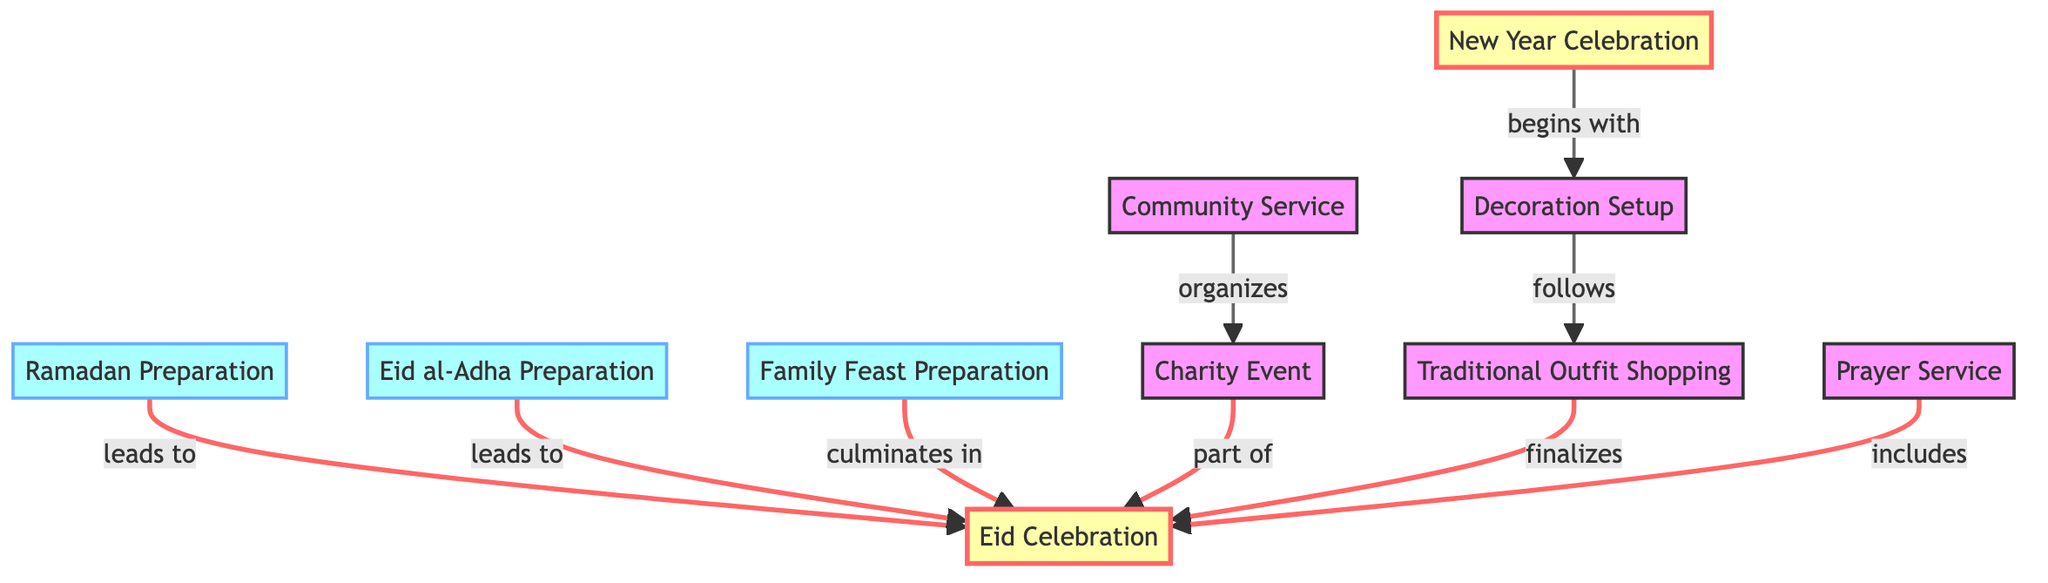What are the nodes representing preparation activities? The nodes that represent preparation activities are identified in the diagram as any node leading to the Eid Celebration. These include Ramadan Preparation, Eid al-Adha Preparation, Family Feast Preparation, Decoration Setup, and Traditional Outfit Shopping.
Answer: Ramadan Preparation, Eid al-Adha Preparation, Family Feast Preparation, Decoration Setup, Traditional Outfit Shopping How many edges are there in the diagram? An edge represents a connection or relationship between two nodes. By counting the connections provided in the data, we find there are 9 edges in total connecting various activities and events.
Answer: 9 Which node leads to Eid Celebration along with Family Feast Preparation? Analyzing the edges, both Ramadan Preparation and Eid al-Adha Preparation lead to the Eid Celebration alongside Family Feast Preparation, indicating multiple paths to the same celebration event.
Answer: Ramadan Preparation, Eid al-Adha Preparation What event occurs before Traditional Outfit Shopping? The diagram indicates that Decoration Setup leads to Traditional Outfit Shopping, as it is the activity that directly precedes it. Examining the directed edges lays this sequence out clearly.
Answer: Decoration Setup Which activities are part of the New Year Celebration? The diagram shows that Decoration Setup is the initial activity that commences the New Year Celebration, which sets the tone for the subsequent preparations and celebrations associated with it.
Answer: Decoration Setup What relationships format are used to describe connections in the diagram? The relationships in the diagram are described using directed edges such as "leads to," "culminates in," and "includes." These labels clarify how each node interacts with the next, illustrating a clear flow of activities.
Answer: leads to, culminates in, includes What is the final step depicted in the preparation for Eid Celebration? According to the diagram, Traditional Outfit Shopping is the last preparation step that finalizes the arrangements for the Eid Celebration, showcasing the sequence of activities leading to the event.
Answer: Traditional Outfit Shopping Which event is mentioned as part of the Community Service? The event organized through Community Service, according to the connections in the diagram, is the Charity Event, which plays an integral role in the overall celebrations by connecting back to the Eid Celebration.
Answer: Charity Event 